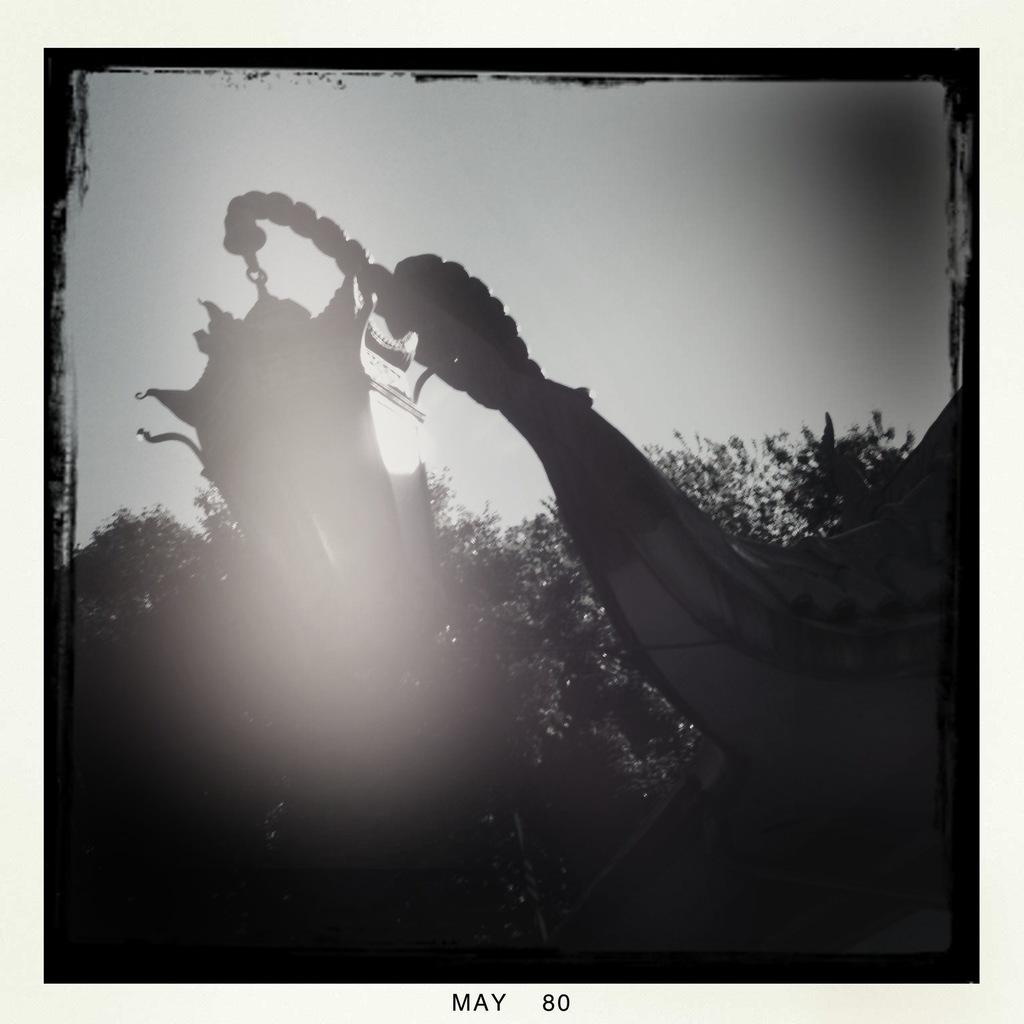What type of vegetation can be seen in the image? There are trees in the image. What part of the natural environment is visible in the image? The sky is visible in the background of the image. Is there any text present in the image? Yes, there is some text at the bottom of the image. How many planes are flying over the trees in the image? There are no planes visible in the image; it only features trees and text. What type of mark is present on the trees in the image? There are no marks visible on the trees in the image. 